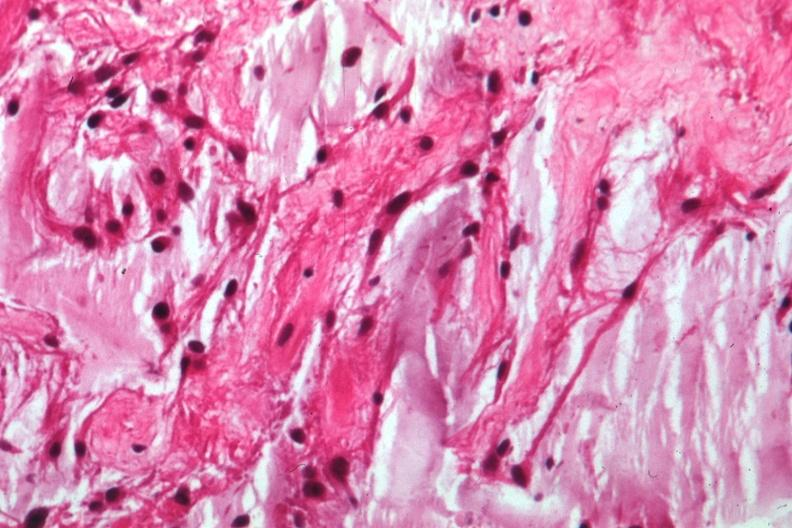does this image show glioma?
Answer the question using a single word or phrase. Yes 